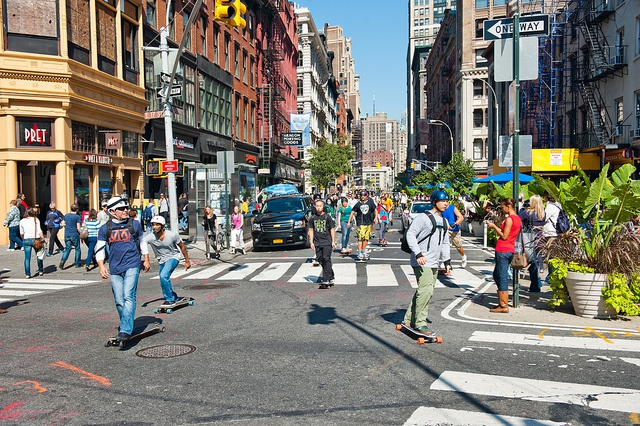Describe the objects in this image and their specific colors. I can see potted plant in tan, olive, black, and gray tones, people in tan, black, lightgray, darkgray, and gray tones, people in tan, lightgray, darkgray, black, and gray tones, people in tan, gray, blue, and black tones, and car in tan, black, darkblue, blue, and gray tones in this image. 